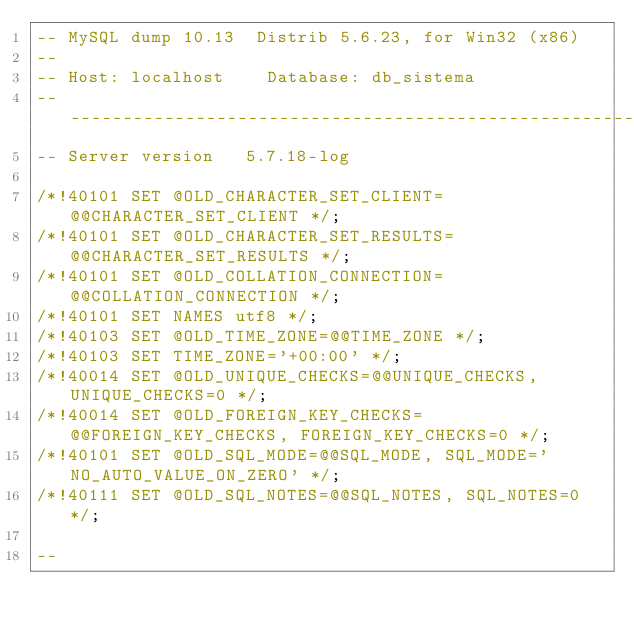<code> <loc_0><loc_0><loc_500><loc_500><_SQL_>-- MySQL dump 10.13  Distrib 5.6.23, for Win32 (x86)
--
-- Host: localhost    Database: db_sistema
-- ------------------------------------------------------
-- Server version	5.7.18-log

/*!40101 SET @OLD_CHARACTER_SET_CLIENT=@@CHARACTER_SET_CLIENT */;
/*!40101 SET @OLD_CHARACTER_SET_RESULTS=@@CHARACTER_SET_RESULTS */;
/*!40101 SET @OLD_COLLATION_CONNECTION=@@COLLATION_CONNECTION */;
/*!40101 SET NAMES utf8 */;
/*!40103 SET @OLD_TIME_ZONE=@@TIME_ZONE */;
/*!40103 SET TIME_ZONE='+00:00' */;
/*!40014 SET @OLD_UNIQUE_CHECKS=@@UNIQUE_CHECKS, UNIQUE_CHECKS=0 */;
/*!40014 SET @OLD_FOREIGN_KEY_CHECKS=@@FOREIGN_KEY_CHECKS, FOREIGN_KEY_CHECKS=0 */;
/*!40101 SET @OLD_SQL_MODE=@@SQL_MODE, SQL_MODE='NO_AUTO_VALUE_ON_ZERO' */;
/*!40111 SET @OLD_SQL_NOTES=@@SQL_NOTES, SQL_NOTES=0 */;

--</code> 